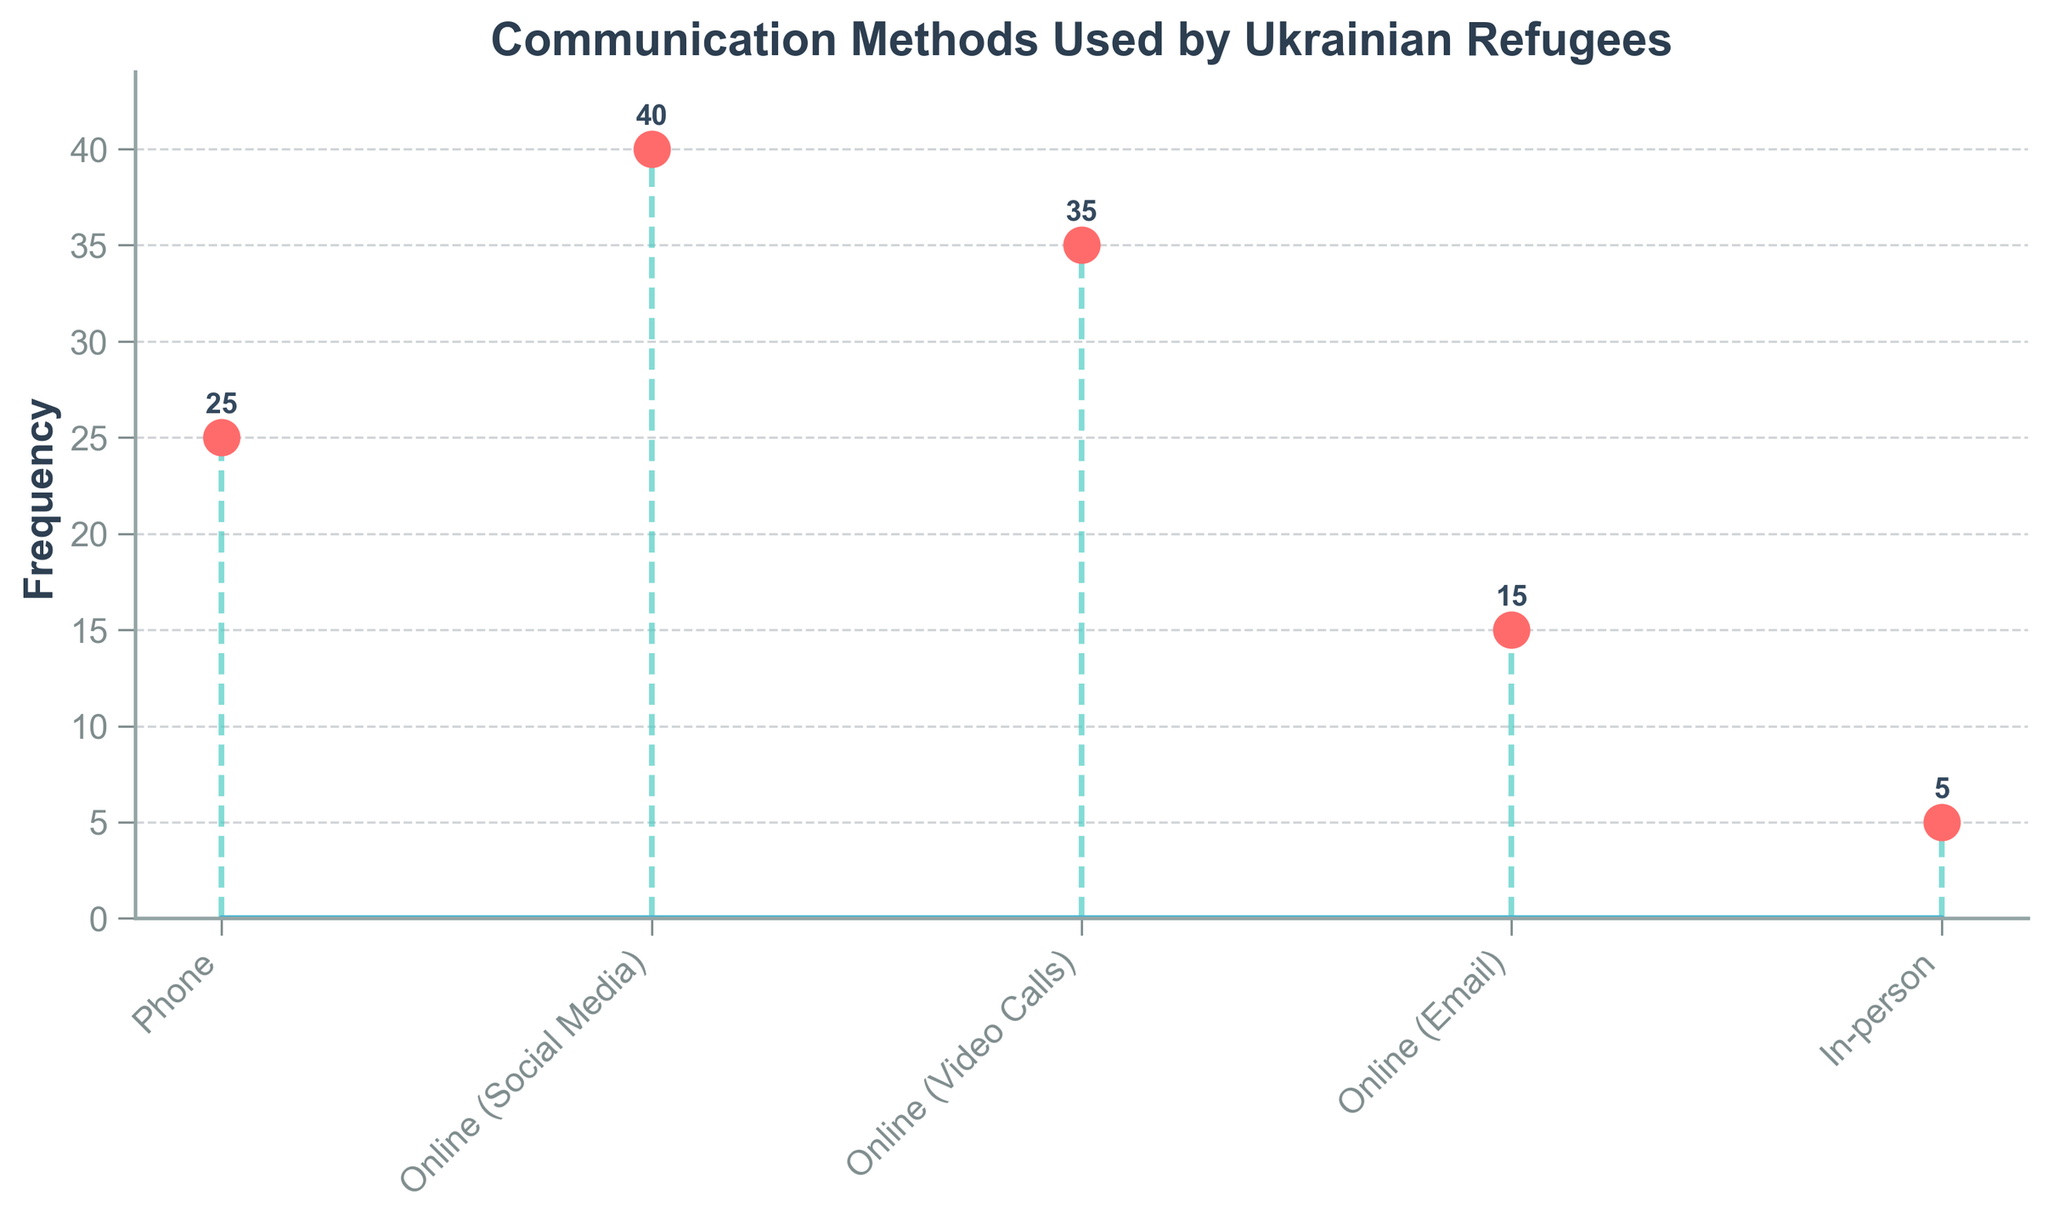what is the title of the plot? The title is usually displayed at the top of the figure. Reading it helps to understand the content immediately. The title of the plot is "Communication Methods Used by Ukrainian Refugees".
Answer: Communication Methods Used by Ukrainian Refugees How many modes of communication are represented in the plot? By counting the individual data points along the x-axis, you can determine the number of modes of communication. There are 5 modes of communication: Phone, Online (Social Media), Online (Video Calls), Online (Email), and In-person.
Answer: 5 What is the frequency for Online (Video Calls)? Locate the "Online (Video Calls)" along the x-axis and follow the stem up to the y-axis to read the value. The frequency is 35.
Answer: 35 Which mode of communication has the highest frequency? Compare the peaks of all the stems to determine which one is the tallest. The mode of communication with the highest frequency is "Online (Social Media)" with a frequency of 40.
Answer: Online (Social Media) What is the least used mode of communication? Identify the shortest stem in the plot. The least used mode of communication is "In-person" with a frequency of 5.
Answer: In-person What is the combined frequency of all online communication modes? The modes of online communication are "Online (Social Media)", "Online (Video Calls)", and "Online (Email)". Sum their frequencies: 40 + 35 + 15 = 90.
Answer: 90 How much more frequent is "Online (Social Media)" compared to "Phone"? Subtract the frequency of "Phone" from the frequency of "Online (Social Media)": 40 - 25 = 15.
Answer: 15 What is the difference between the frequency of the most used mode and the least used mode of communication? Subtract the frequency of the least used mode, "In-person", from the most used mode, "Online (Social Media)": 40 - 5 = 35.
Answer: 35 What percentage of the total frequency does "Phone" represent? First, calculate the total frequency by summing up all frequencies: 25+40+35+15+5=120. Then, divide the frequency of "Phone" by the total frequency and multiply by 100: (25 / 120) * 100 ≈ 20.83%.
Answer: 20.83% What is the average frequency across all modes of communication? Sum up all frequencies and then divide by the number of modes. The total frequency is 120, and there are 5 modes, so: 120 / 5 = 24.
Answer: 24 